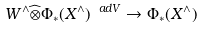Convert formula to latex. <formula><loc_0><loc_0><loc_500><loc_500>\ W ^ { \wedge } \widehat { \otimes } \Phi _ { * } ( X ^ { \wedge } ) ^ { \ a d V } \rightarrow \Phi _ { * } ( X ^ { \wedge } )</formula> 